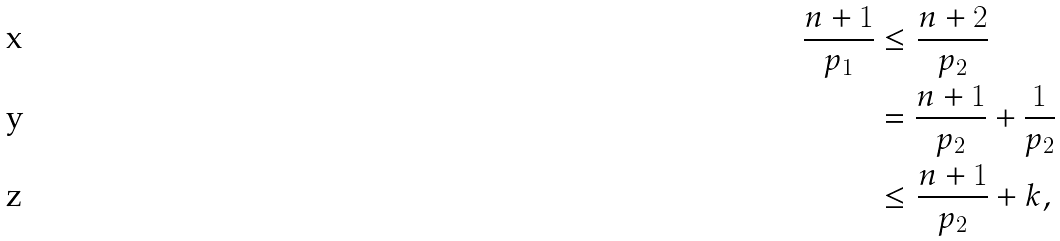Convert formula to latex. <formula><loc_0><loc_0><loc_500><loc_500>\frac { n + 1 } { p _ { 1 } } & \leq \frac { n + 2 } { p _ { 2 } } \\ & = \frac { n + 1 } { p _ { 2 } } + \frac { 1 } { p _ { 2 } } \\ & \leq \frac { n + 1 } { p _ { 2 } } + k ,</formula> 